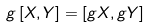Convert formula to latex. <formula><loc_0><loc_0><loc_500><loc_500>g \, [ X , Y ] = [ g X , g Y ]</formula> 